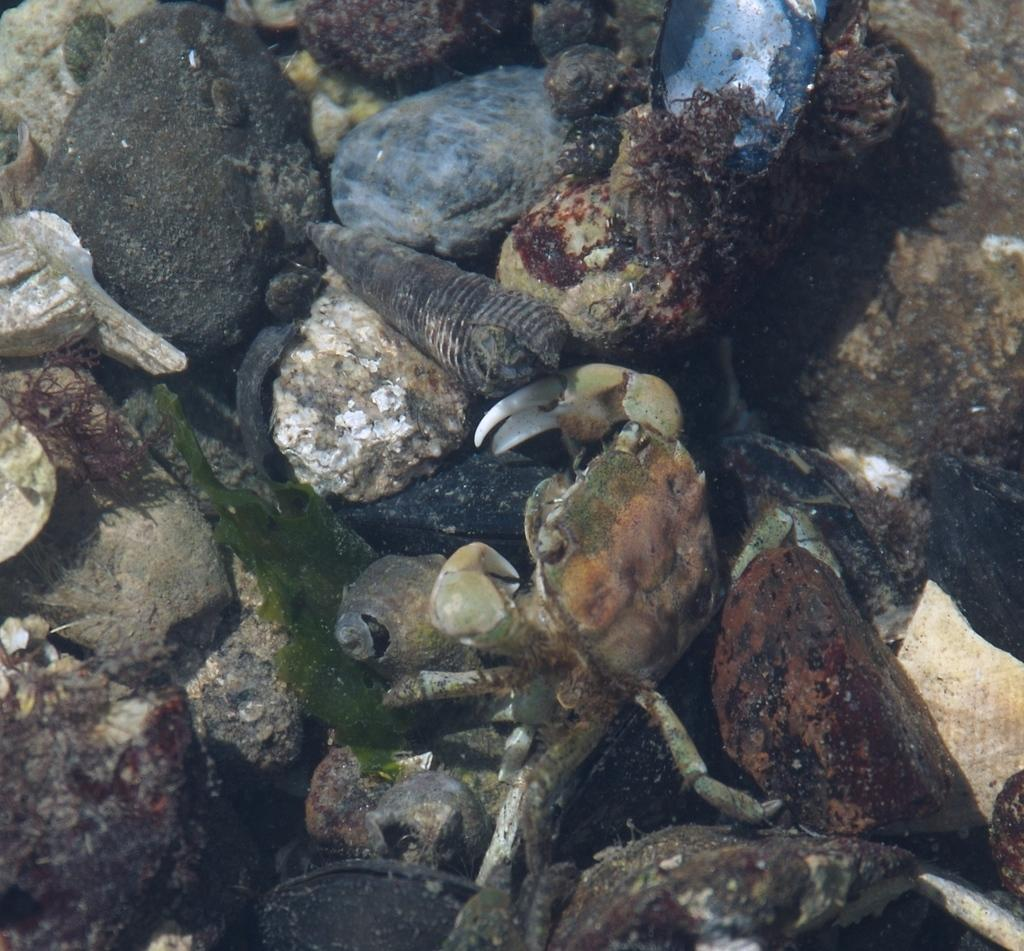What type of animal is present in the image? There is a crab in the image. What other objects can be seen in the image? There is a group of shells and stones visible in the image. What type of vegetation is present in the water in the image? There are plants in the water in the image. What type of line can be seen connecting the crab to the shells in the image? There is no line connecting the crab to the shells in the image. What type of knife is visible in the image? There is no knife present in the image. 